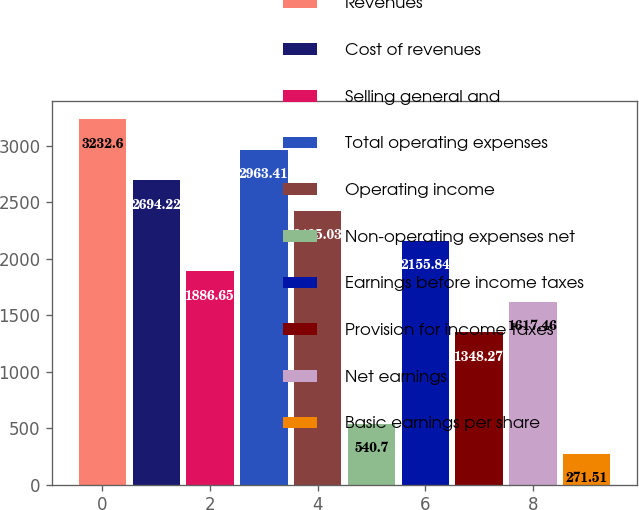Convert chart to OTSL. <chart><loc_0><loc_0><loc_500><loc_500><bar_chart><fcel>Revenues<fcel>Cost of revenues<fcel>Selling general and<fcel>Total operating expenses<fcel>Operating income<fcel>Non-operating expenses net<fcel>Earnings before income taxes<fcel>Provision for income taxes<fcel>Net earnings<fcel>Basic earnings per share<nl><fcel>3232.6<fcel>2694.22<fcel>1886.65<fcel>2963.41<fcel>2425.03<fcel>540.7<fcel>2155.84<fcel>1348.27<fcel>1617.46<fcel>271.51<nl></chart> 